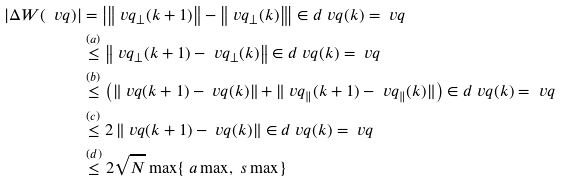Convert formula to latex. <formula><loc_0><loc_0><loc_500><loc_500>\left | \Delta W ( \ v q ) \right | & = \left | \left \| \ v q _ { \perp } ( k + 1 ) \right \| - \left \| \ v q _ { \perp } ( k ) \right \| \right | \in d { \ v q ( k ) = \ v q } \\ & \stackrel { ( a ) } { \leq } \left \| \ v q _ { \perp } ( k + 1 ) - \ v q _ { \perp } ( k ) \right \| \in d { \ v q ( k ) = \ v q } \\ & \stackrel { ( b ) } { \leq } \left ( \left \| \ v q ( k + 1 ) - \ v q ( k ) \right \| + \| \ v q _ { \| } ( k + 1 ) - \ v q _ { \| } ( k ) \| \right ) \in d { \ v q ( k ) = \ v q } \\ & \stackrel { ( c ) } { \leq } 2 \left \| \ v q ( k + 1 ) - \ v q ( k ) \right \| \in d { \ v q ( k ) = \ v q } \\ & \stackrel { ( d ) } { \leq } 2 \sqrt { N } \max \{ \ a \max , \ s \max \}</formula> 